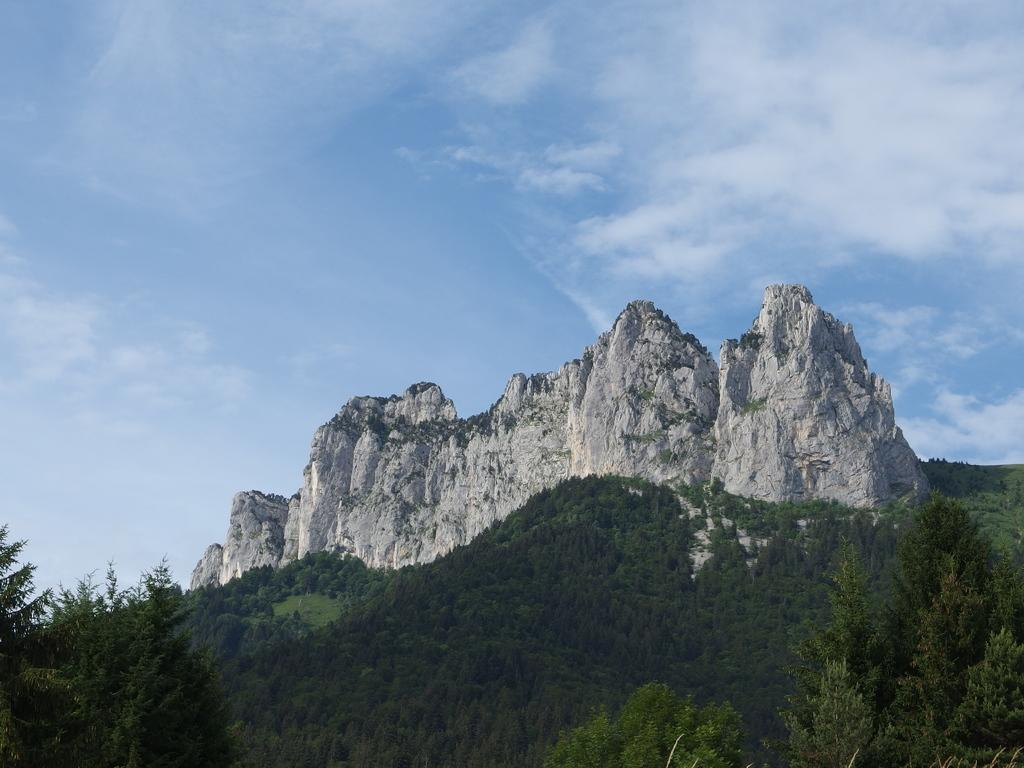What type of natural features can be seen in the image? There are trees and mountains in the image. What is visible in the background of the image? The sky is visible in the background of the image. What can be seen in the sky? Clouds are present in the sky. What type of cloth is draped over the shelf in the image? There is no shelf or cloth present in the image; it features trees, mountains, and a sky with clouds. 